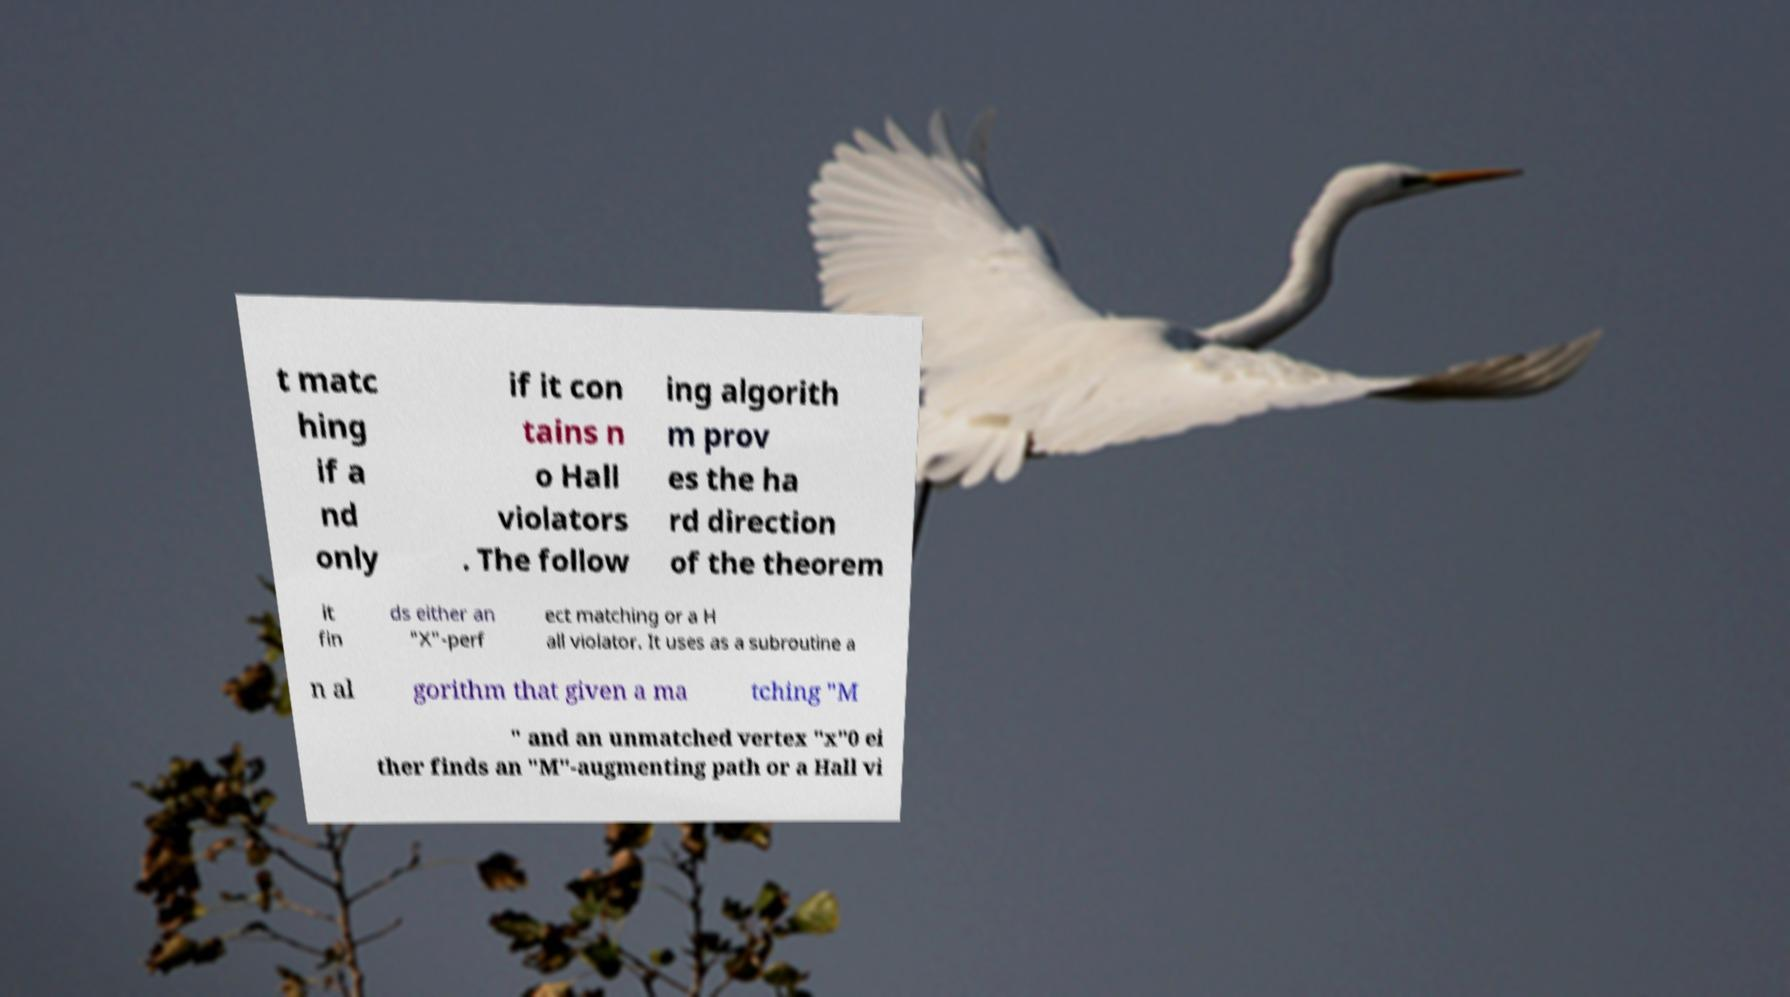I need the written content from this picture converted into text. Can you do that? t matc hing if a nd only if it con tains n o Hall violators . The follow ing algorith m prov es the ha rd direction of the theorem it fin ds either an "X"-perf ect matching or a H all violator. It uses as a subroutine a n al gorithm that given a ma tching "M " and an unmatched vertex "x"0 ei ther finds an "M"-augmenting path or a Hall vi 